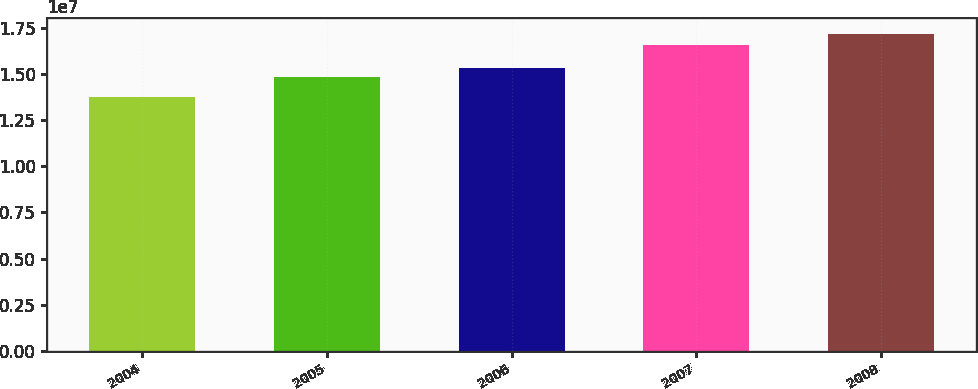Convert chart to OTSL. <chart><loc_0><loc_0><loc_500><loc_500><bar_chart><fcel>2004<fcel>2005<fcel>2006<fcel>2007<fcel>2008<nl><fcel>1.3757e+07<fcel>1.4818e+07<fcel>1.5309e+07<fcel>1.6586e+07<fcel>1.7184e+07<nl></chart> 